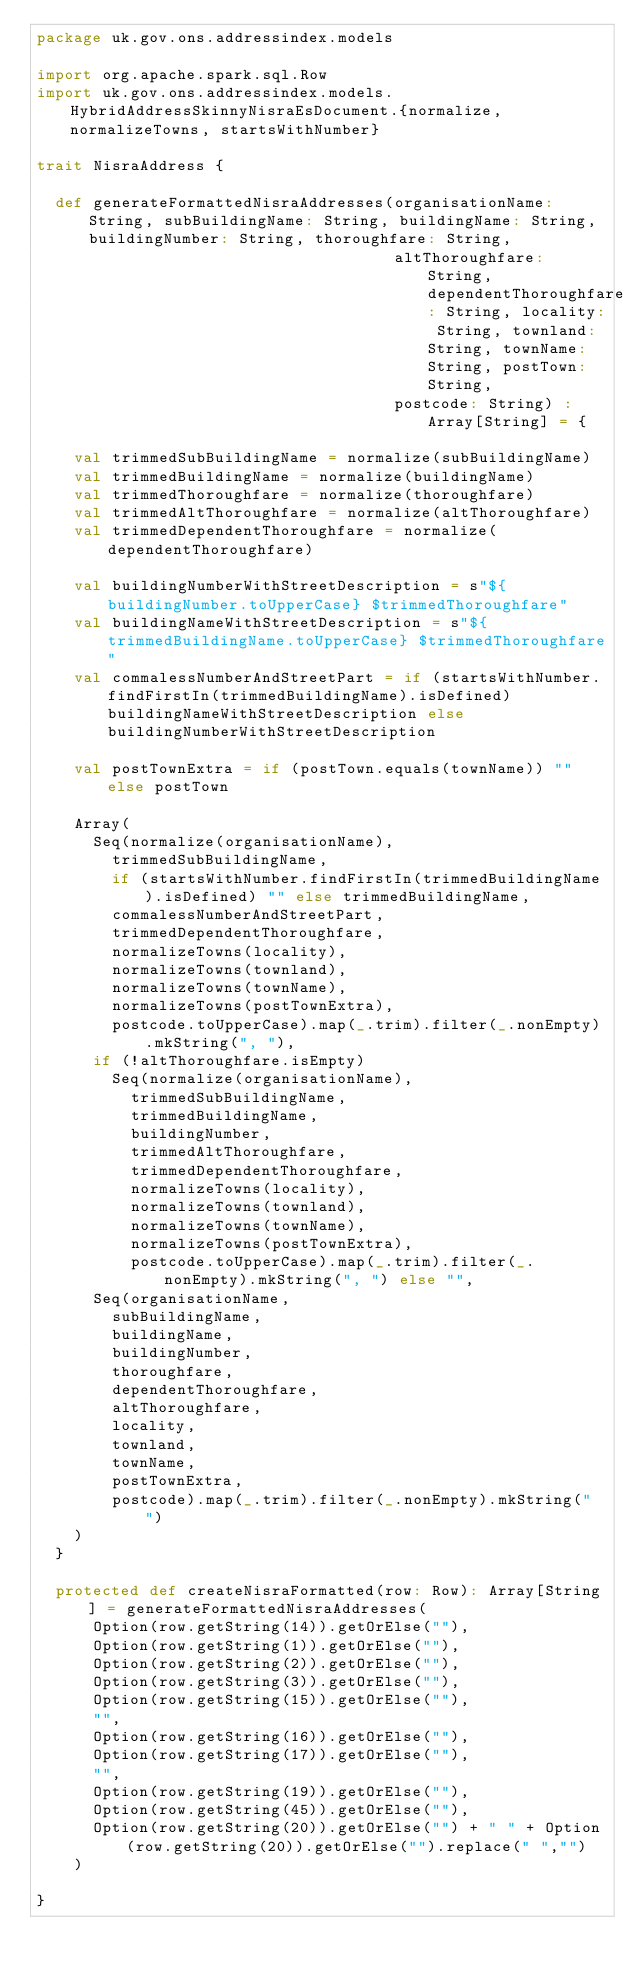Convert code to text. <code><loc_0><loc_0><loc_500><loc_500><_Scala_>package uk.gov.ons.addressindex.models

import org.apache.spark.sql.Row
import uk.gov.ons.addressindex.models.HybridAddressSkinnyNisraEsDocument.{normalize, normalizeTowns, startsWithNumber}

trait NisraAddress {

  def generateFormattedNisraAddresses(organisationName: String, subBuildingName: String, buildingName: String, buildingNumber: String, thoroughfare: String,
                                      altThoroughfare: String, dependentThoroughfare: String, locality: String, townland: String, townName: String, postTown: String,
                                      postcode: String) : Array[String] = {

    val trimmedSubBuildingName = normalize(subBuildingName)
    val trimmedBuildingName = normalize(buildingName)
    val trimmedThoroughfare = normalize(thoroughfare)
    val trimmedAltThoroughfare = normalize(altThoroughfare)
    val trimmedDependentThoroughfare = normalize(dependentThoroughfare)

    val buildingNumberWithStreetDescription = s"${buildingNumber.toUpperCase} $trimmedThoroughfare"
    val buildingNameWithStreetDescription = s"${trimmedBuildingName.toUpperCase} $trimmedThoroughfare"
    val commalessNumberAndStreetPart = if (startsWithNumber.findFirstIn(trimmedBuildingName).isDefined) buildingNameWithStreetDescription else buildingNumberWithStreetDescription

    val postTownExtra = if (postTown.equals(townName)) "" else postTown

    Array(
      Seq(normalize(organisationName),
        trimmedSubBuildingName,
        if (startsWithNumber.findFirstIn(trimmedBuildingName).isDefined) "" else trimmedBuildingName,
        commalessNumberAndStreetPart,
        trimmedDependentThoroughfare,
        normalizeTowns(locality),
        normalizeTowns(townland),
        normalizeTowns(townName),
        normalizeTowns(postTownExtra),
        postcode.toUpperCase).map(_.trim).filter(_.nonEmpty).mkString(", "),
      if (!altThoroughfare.isEmpty)
        Seq(normalize(organisationName),
          trimmedSubBuildingName,
          trimmedBuildingName,
          buildingNumber,
          trimmedAltThoroughfare,
          trimmedDependentThoroughfare,
          normalizeTowns(locality),
          normalizeTowns(townland),
          normalizeTowns(townName),
          normalizeTowns(postTownExtra),
          postcode.toUpperCase).map(_.trim).filter(_.nonEmpty).mkString(", ") else "",
      Seq(organisationName,
        subBuildingName,
        buildingName,
        buildingNumber,
        thoroughfare,
        dependentThoroughfare,
        altThoroughfare,
        locality,
        townland,
        townName,
        postTownExtra,
        postcode).map(_.trim).filter(_.nonEmpty).mkString(" ")
    )
  }

  protected def createNisraFormatted(row: Row): Array[String] = generateFormattedNisraAddresses(
      Option(row.getString(14)).getOrElse(""),
      Option(row.getString(1)).getOrElse(""),
      Option(row.getString(2)).getOrElse(""),
      Option(row.getString(3)).getOrElse(""),
      Option(row.getString(15)).getOrElse(""),
      "",
      Option(row.getString(16)).getOrElse(""),
      Option(row.getString(17)).getOrElse(""),
      "",
      Option(row.getString(19)).getOrElse(""),
      Option(row.getString(45)).getOrElse(""),
      Option(row.getString(20)).getOrElse("") + " " + Option(row.getString(20)).getOrElse("").replace(" ","")
    )

}</code> 